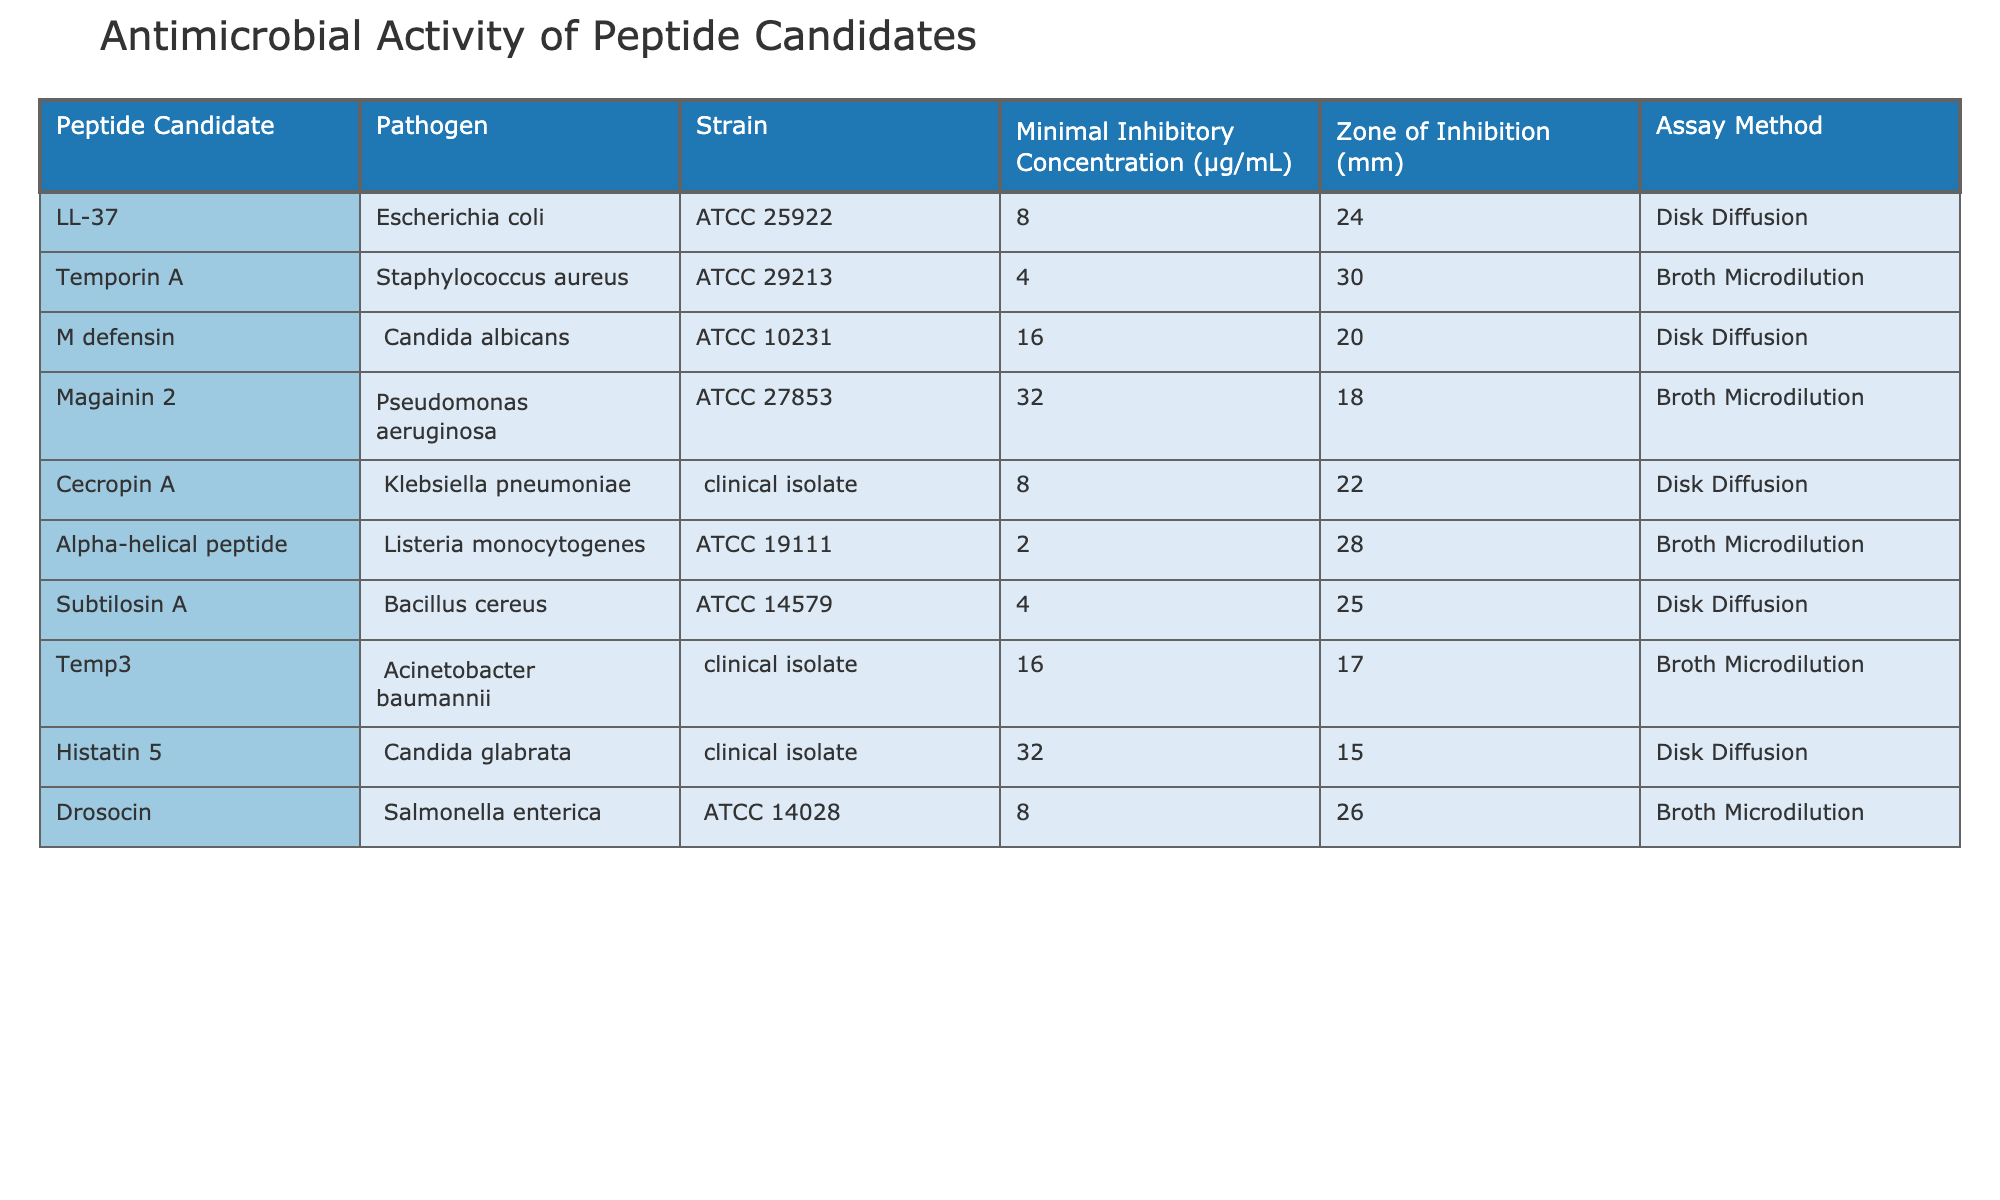What is the Minimal Inhibitory Concentration for LL-37 against Escherichia coli? The table shows that the Minimal Inhibitory Concentration for LL-37 against Escherichia coli is listed as 8 µg/mL.
Answer: 8 µg/mL Which peptide candidate has the highest Zone of Inhibition against Staphylococcus aureus? The table indicates that Temporin A has the highest Zone of Inhibition of 30 mm against Staphylococcus aureus.
Answer: Temporin A Is there a peptide candidate that exhibits a Zone of Inhibition of 15 mm or less? The table shows that Histatin 5 has a Zone of Inhibition of 15 mm, thus confirming that there is at least one peptide candidate that meets this criterion.
Answer: Yes What is the average Minimal Inhibitory Concentration of all peptide candidates tested? The Minimal Inhibitory Concentrations are: 8, 4, 16, 32, 8, 2, 4, 16, 32, and 8. Summing these gives 8 + 4 + 16 + 32 + 8 + 2 + 4 + 16 + 32 + 8 = 132, and dividing by 10 (the number of entries) gives 132/10 = 13.2.
Answer: 13.2 µg/mL Which peptide candidate is effective against Candida albicans, and what is its Minimal Inhibitory Concentration? The table lists M defensin as the peptide candidate effective against Candida albicans with a Minimal Inhibitory Concentration of 16 µg/mL.
Answer: M defensin, 16 µg/mL How many peptide candidates showed effectiveness against Acinetobacter baumannii? The table shows that only one peptide candidate, Temp3, is listed as being effective against Acinetobacter baumannii; therefore, the count is one.
Answer: 1 Are all tested strains represented in the table? By examining the table, it is clear that several strains are represented, including Escherichia coli, Staphylococcus aureus, Candida albicans, and others, confirming that not all strains are tested as there are many pathogens not listed.
Answer: No Which peptide candidate has the lowest Minimal Inhibitory Concentration among all tested candidates? The table indicates that Alpha-helical peptide has the lowest Minimal Inhibitory Concentration of 2 µg/mL, confirmed by comparing all values.
Answer: Alpha-helical peptide, 2 µg/mL 